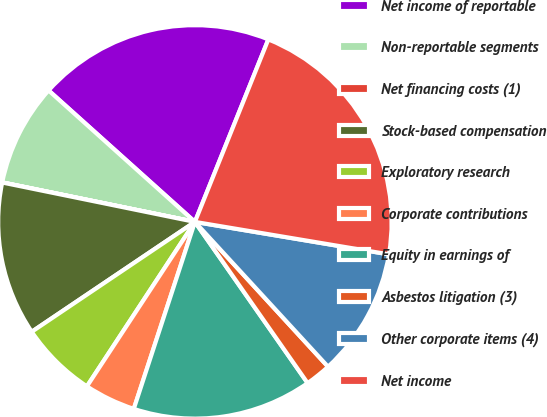Convert chart to OTSL. <chart><loc_0><loc_0><loc_500><loc_500><pie_chart><fcel>Net income of reportable<fcel>Non-reportable segments<fcel>Net financing costs (1)<fcel>Stock-based compensation<fcel>Exploratory research<fcel>Corporate contributions<fcel>Equity in earnings of<fcel>Asbestos litigation (3)<fcel>Other corporate items (4)<fcel>Net income<nl><fcel>19.44%<fcel>8.43%<fcel>0.01%<fcel>12.64%<fcel>6.32%<fcel>4.22%<fcel>14.74%<fcel>2.12%<fcel>10.53%<fcel>21.55%<nl></chart> 